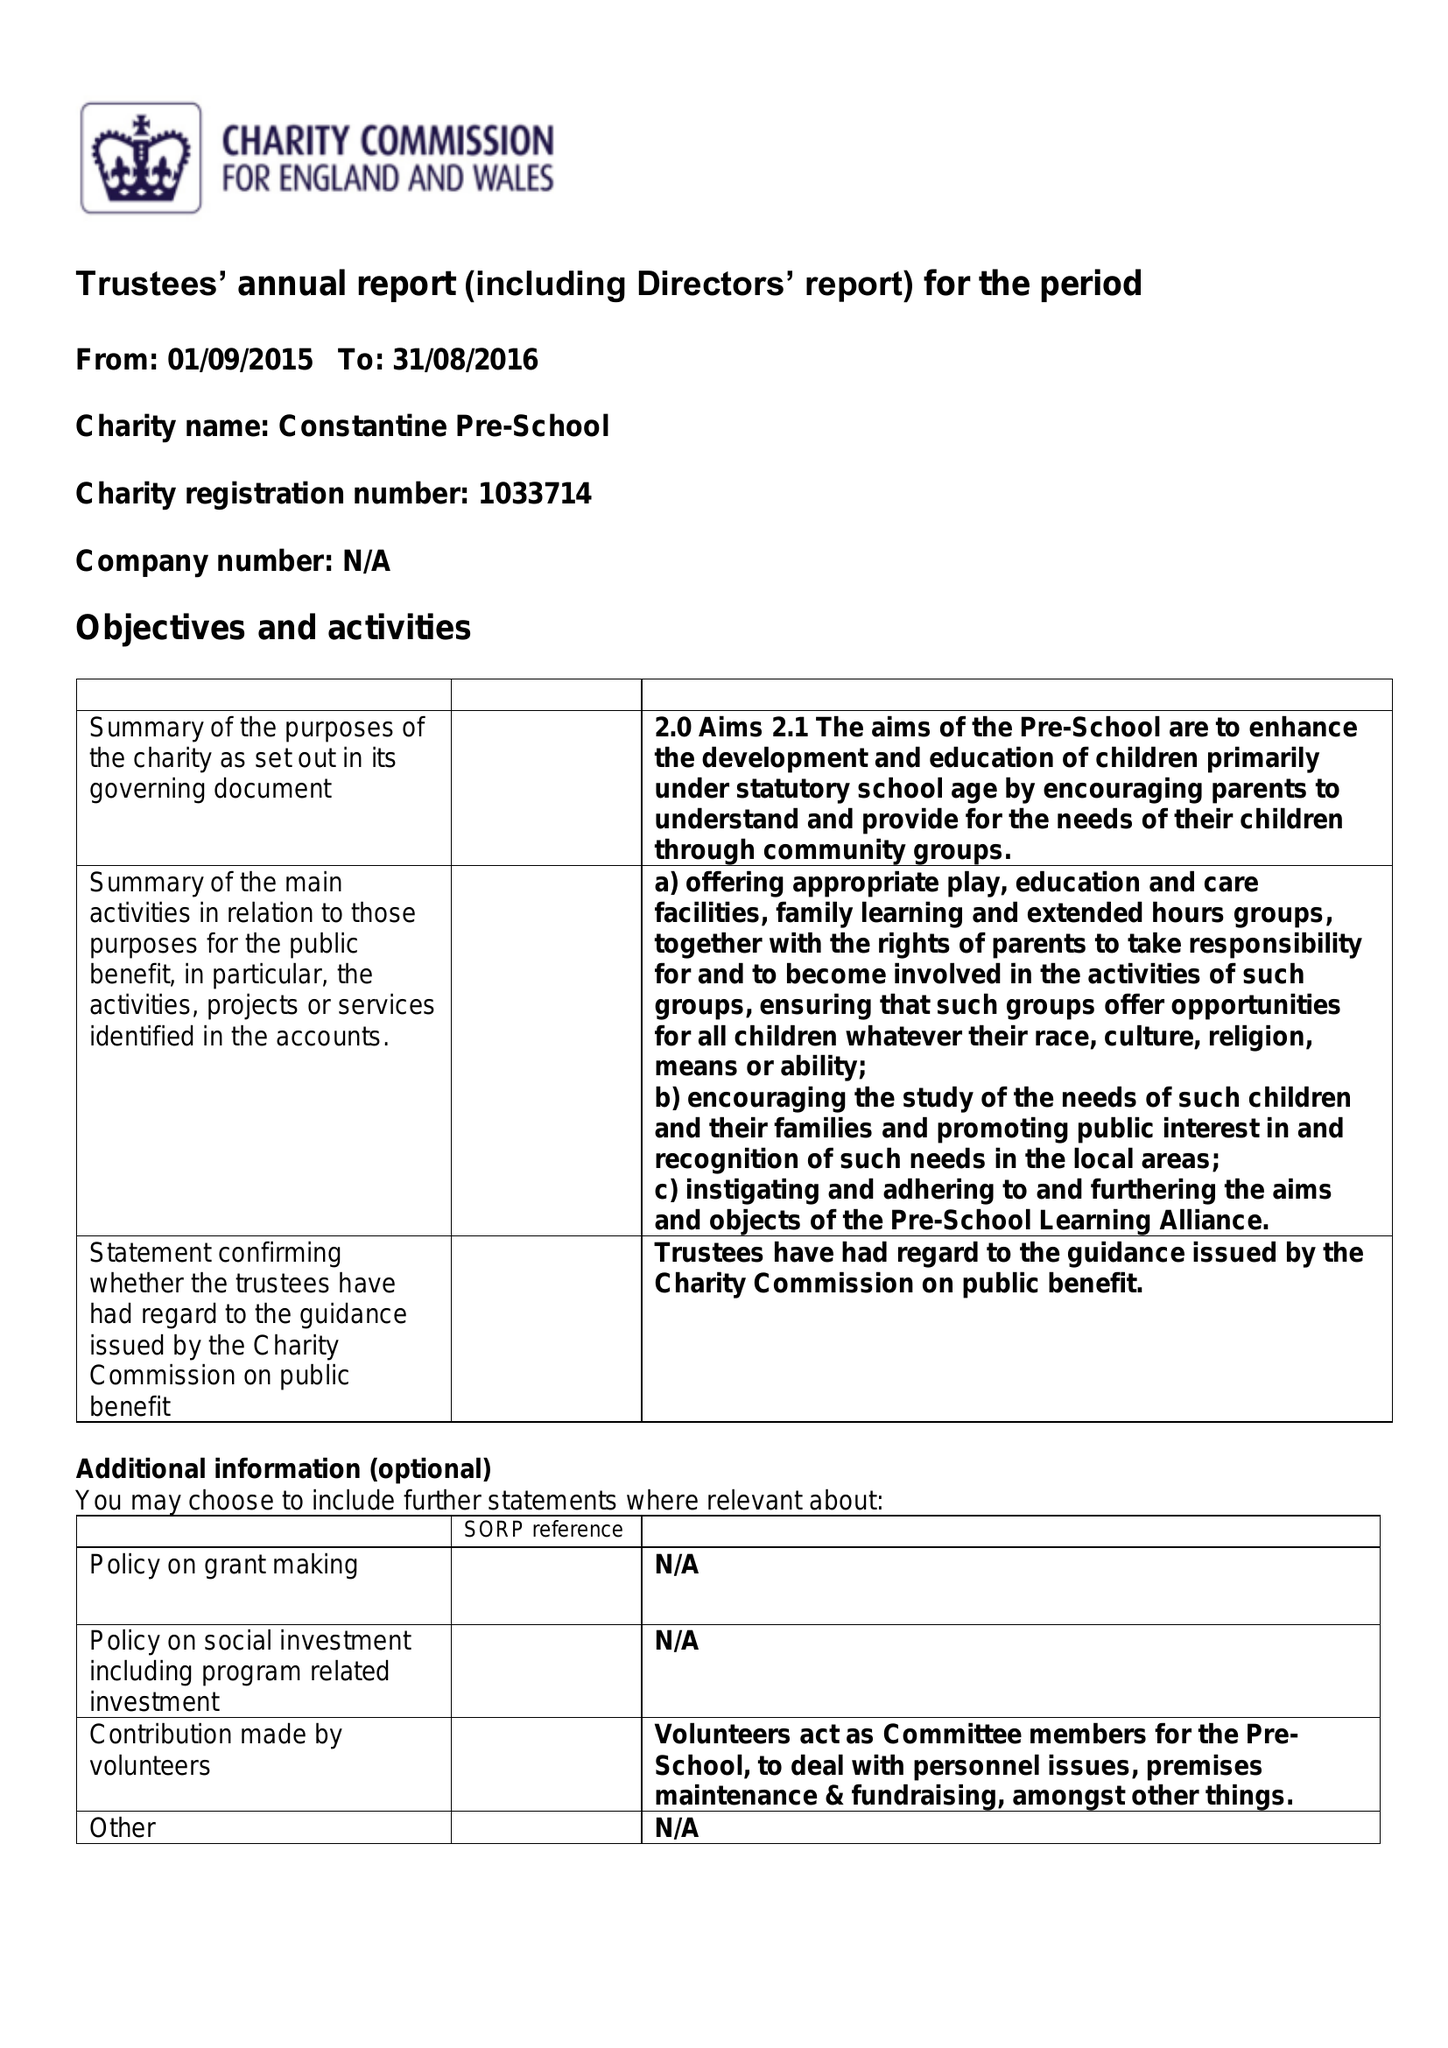What is the value for the report_date?
Answer the question using a single word or phrase. 2016-08-31 